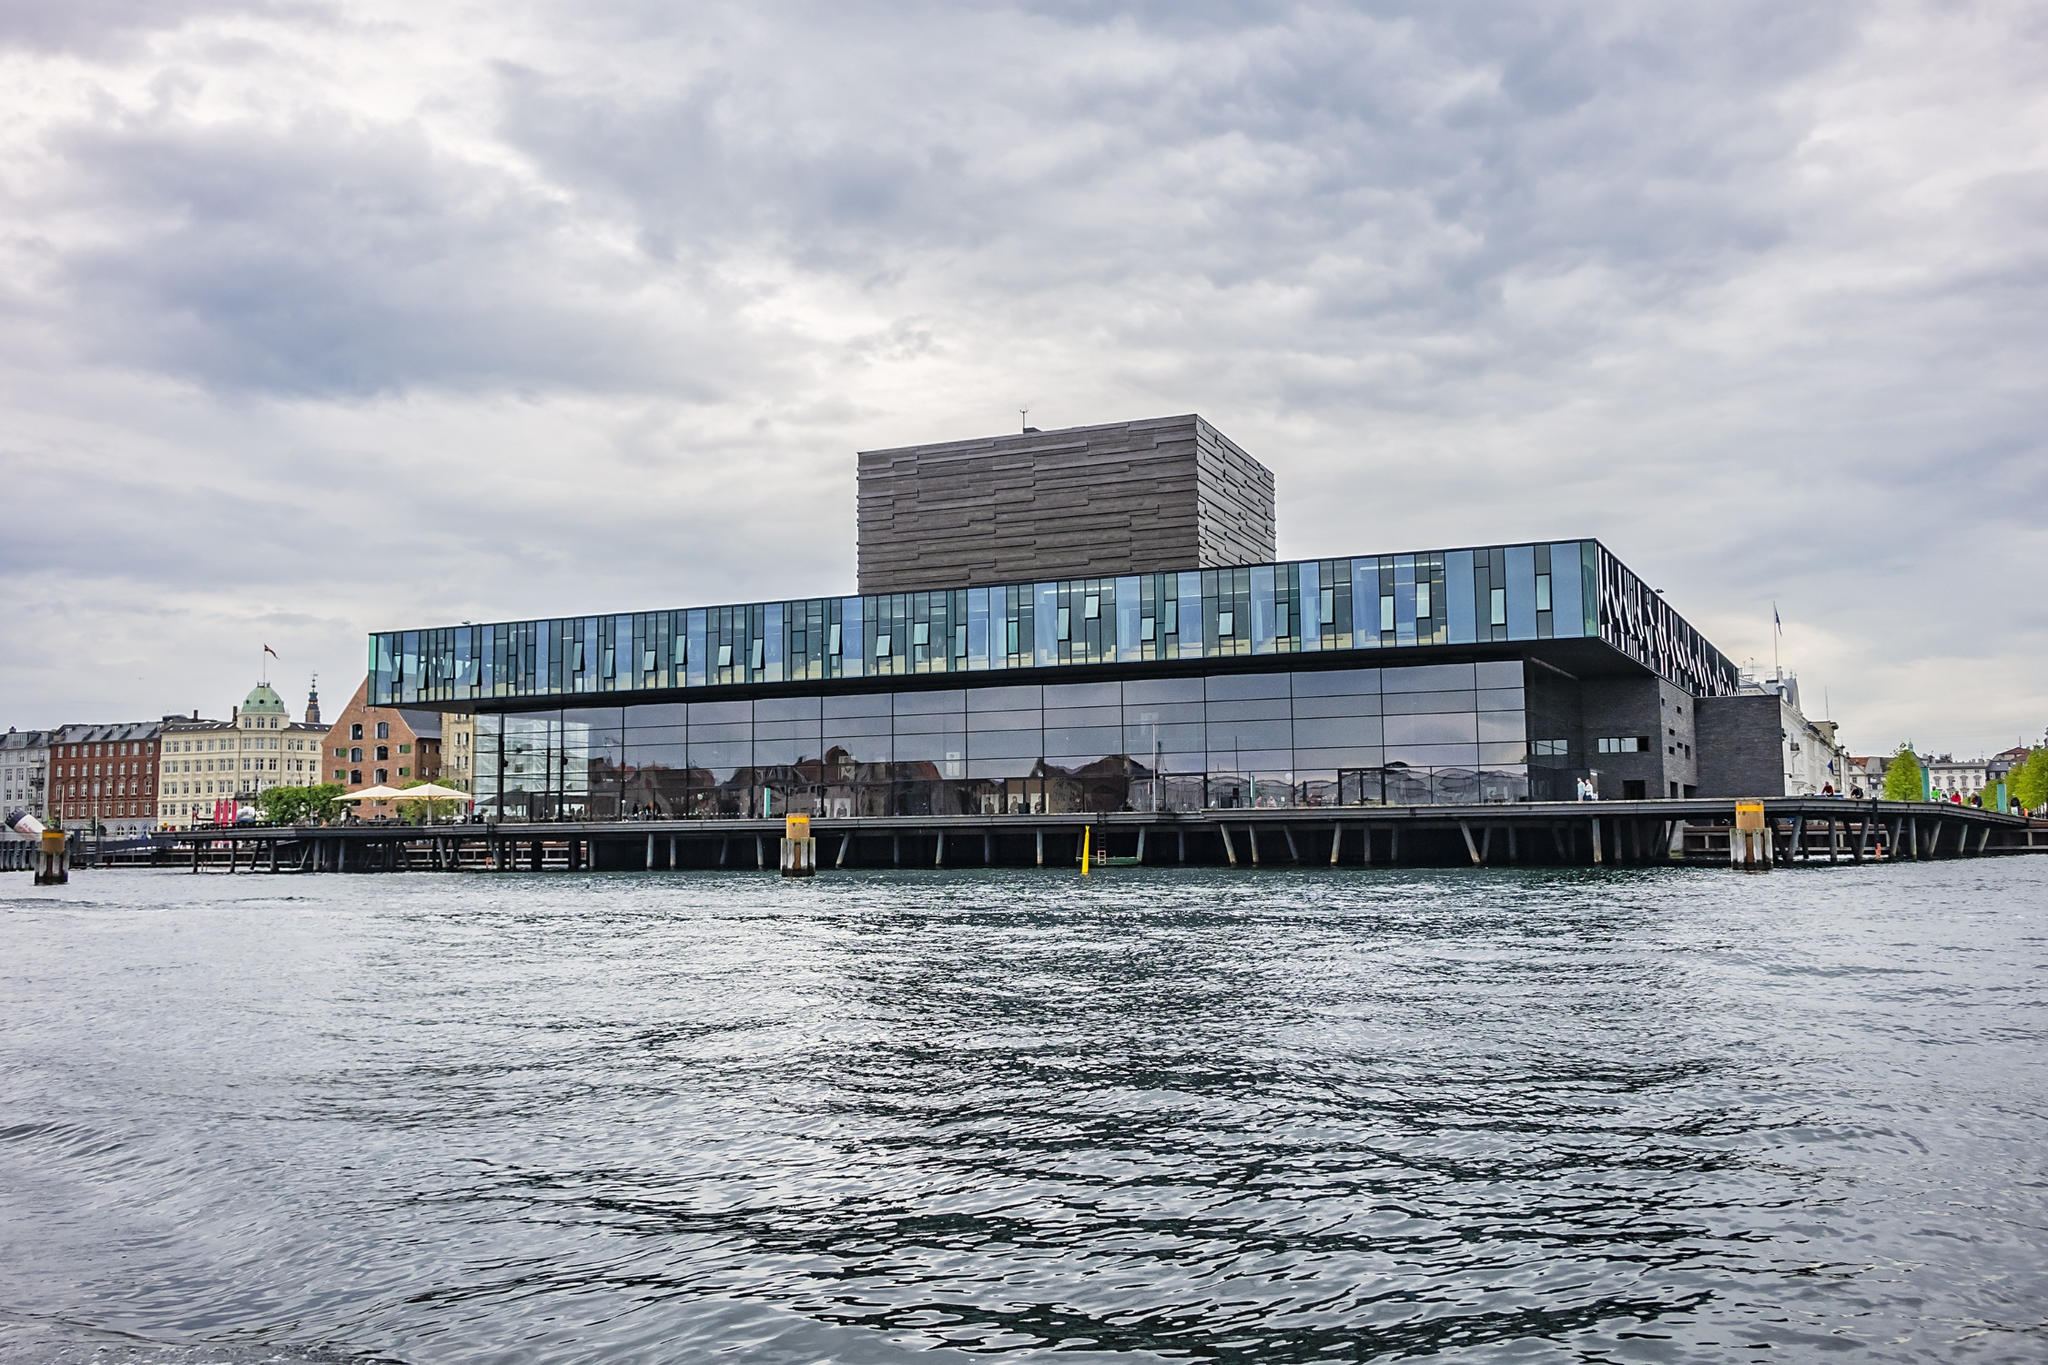Could you discuss the architectural design and significance of the materials used in the Playhouse? The architectural design of the Royal Danish Playhouse is a masterful example of modernist influence, showcasing minimalism and functionality. The exterior is primarily clad in dark Jura Gelb limestone, which provides a stark contrast to the reflective glass that constitutes much of the facade. This choice of materials is not only aesthetic but also functional, as the limestone offers durability and the glass allows natural light to permeate the interiors, enhancing the ambiance for both performers and visitors. The architectural layout is designed to provide uninterrupted views of the waterfront, connecting the audience with the external environment and reinforcing the structure's integration with its surroundings. 